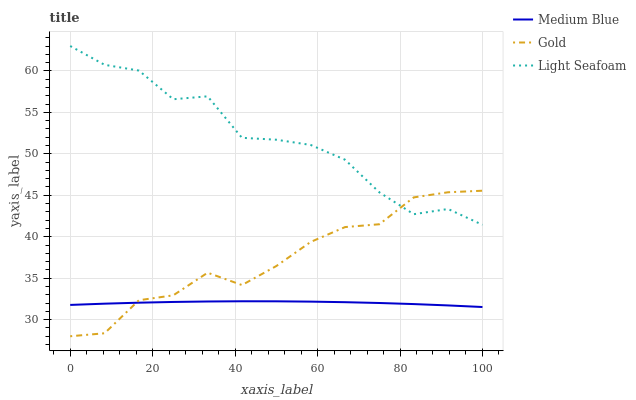Does Medium Blue have the minimum area under the curve?
Answer yes or no. Yes. Does Light Seafoam have the maximum area under the curve?
Answer yes or no. Yes. Does Gold have the minimum area under the curve?
Answer yes or no. No. Does Gold have the maximum area under the curve?
Answer yes or no. No. Is Medium Blue the smoothest?
Answer yes or no. Yes. Is Light Seafoam the roughest?
Answer yes or no. Yes. Is Gold the smoothest?
Answer yes or no. No. Is Gold the roughest?
Answer yes or no. No. Does Gold have the lowest value?
Answer yes or no. Yes. Does Medium Blue have the lowest value?
Answer yes or no. No. Does Light Seafoam have the highest value?
Answer yes or no. Yes. Does Gold have the highest value?
Answer yes or no. No. Is Medium Blue less than Light Seafoam?
Answer yes or no. Yes. Is Light Seafoam greater than Medium Blue?
Answer yes or no. Yes. Does Medium Blue intersect Gold?
Answer yes or no. Yes. Is Medium Blue less than Gold?
Answer yes or no. No. Is Medium Blue greater than Gold?
Answer yes or no. No. Does Medium Blue intersect Light Seafoam?
Answer yes or no. No. 